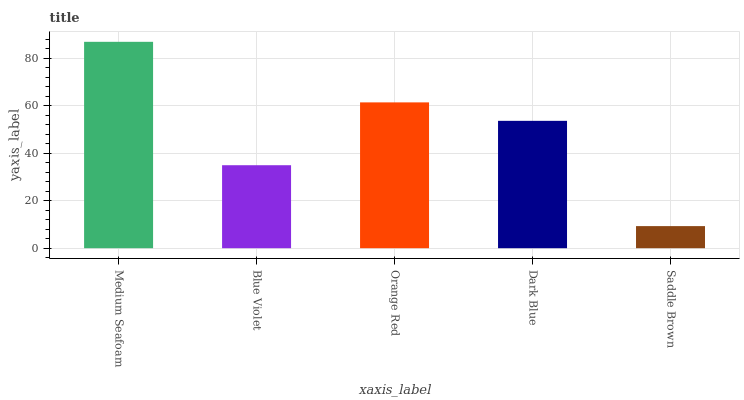Is Saddle Brown the minimum?
Answer yes or no. Yes. Is Medium Seafoam the maximum?
Answer yes or no. Yes. Is Blue Violet the minimum?
Answer yes or no. No. Is Blue Violet the maximum?
Answer yes or no. No. Is Medium Seafoam greater than Blue Violet?
Answer yes or no. Yes. Is Blue Violet less than Medium Seafoam?
Answer yes or no. Yes. Is Blue Violet greater than Medium Seafoam?
Answer yes or no. No. Is Medium Seafoam less than Blue Violet?
Answer yes or no. No. Is Dark Blue the high median?
Answer yes or no. Yes. Is Dark Blue the low median?
Answer yes or no. Yes. Is Blue Violet the high median?
Answer yes or no. No. Is Orange Red the low median?
Answer yes or no. No. 